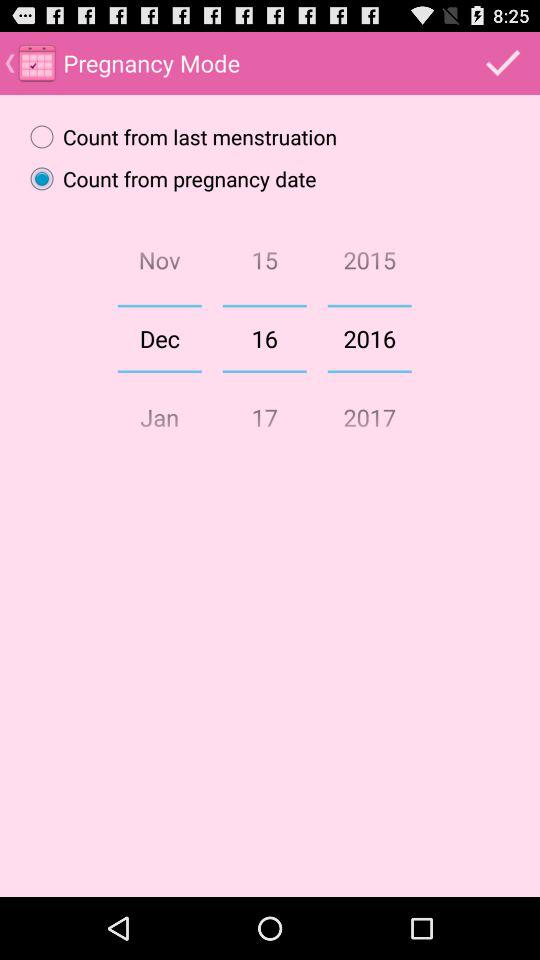What is the selected option in "Pregnancy Mode"? The selected option is "Count from pregnancy date". 